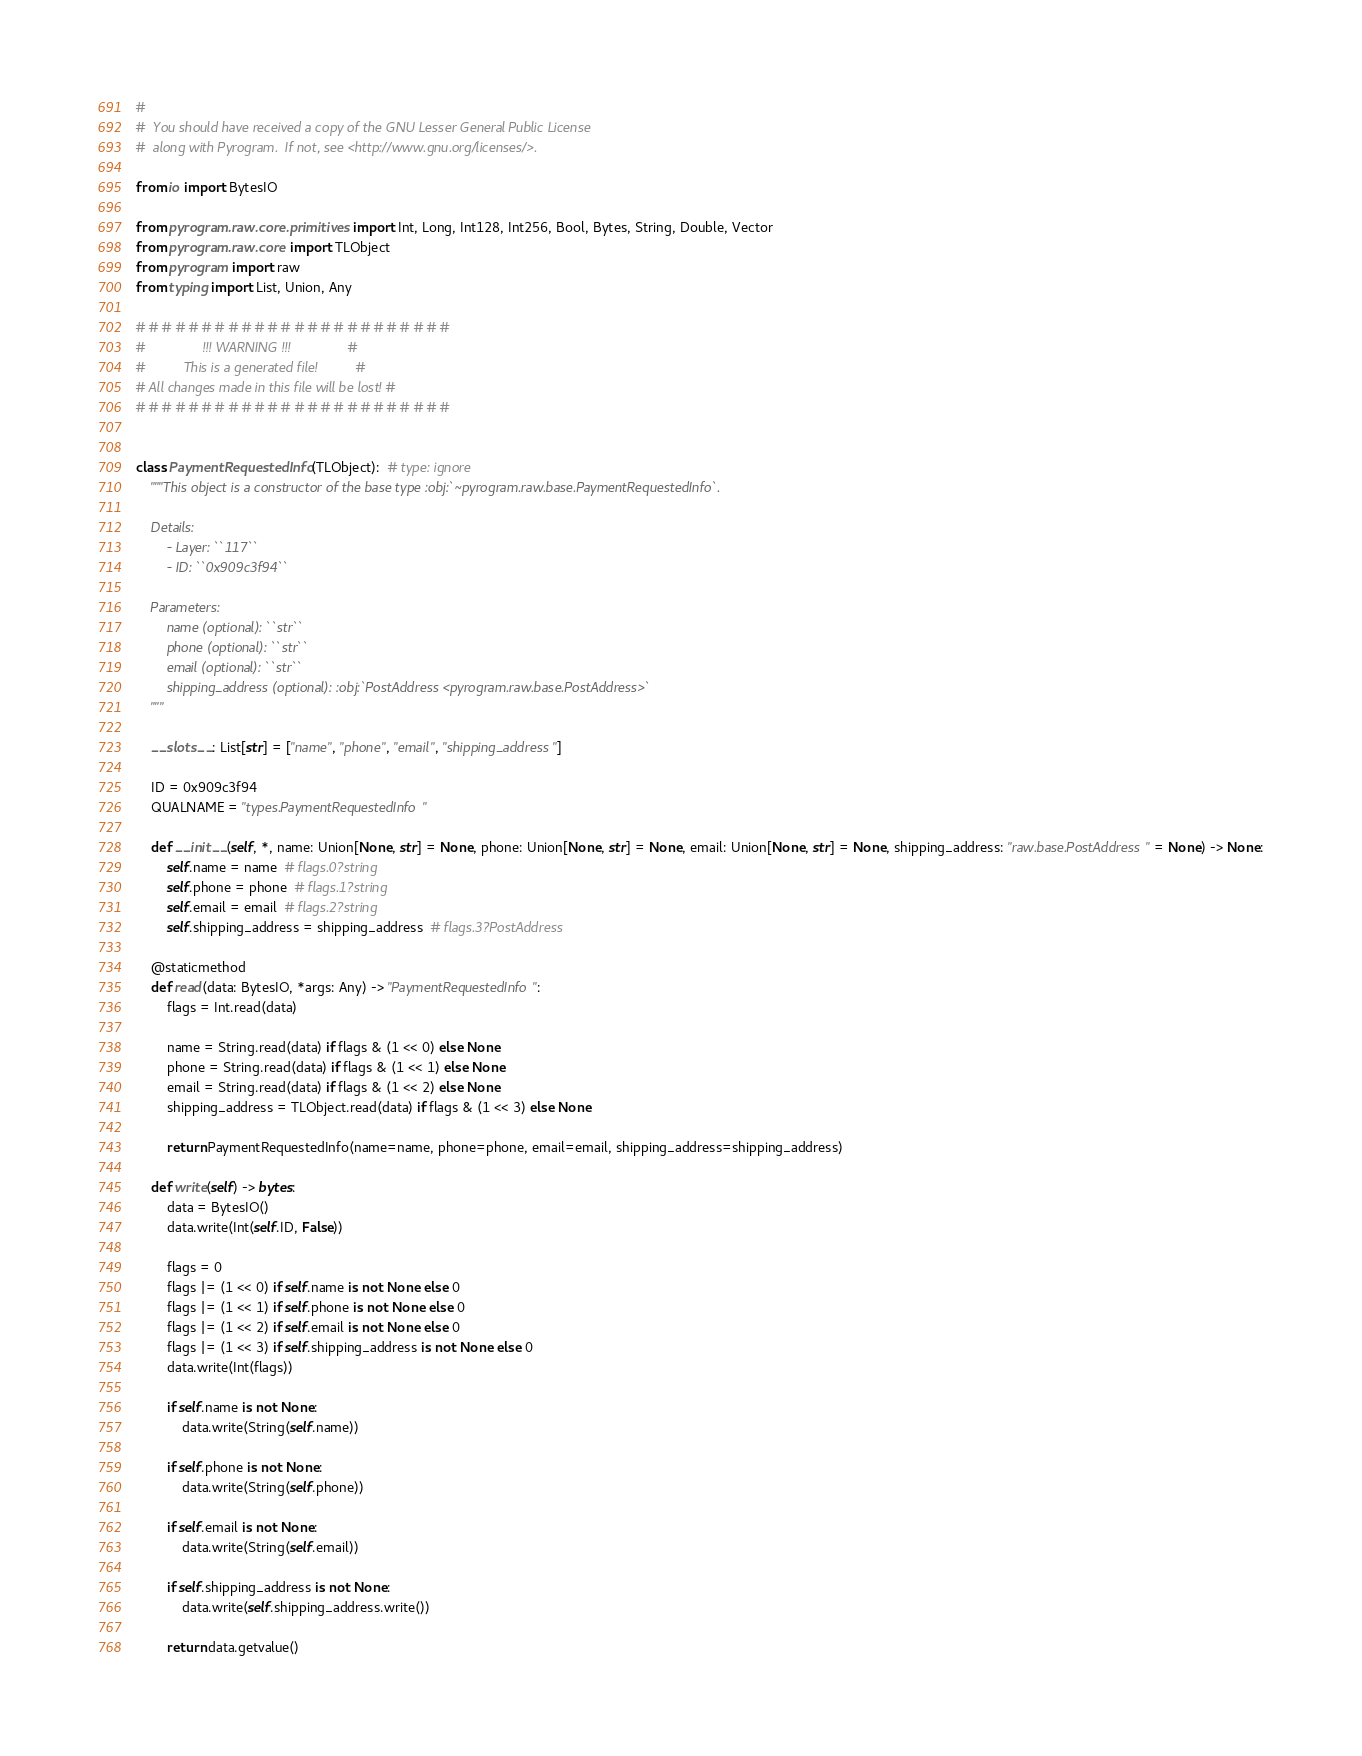Convert code to text. <code><loc_0><loc_0><loc_500><loc_500><_Python_>#
#  You should have received a copy of the GNU Lesser General Public License
#  along with Pyrogram.  If not, see <http://www.gnu.org/licenses/>.

from io import BytesIO

from pyrogram.raw.core.primitives import Int, Long, Int128, Int256, Bool, Bytes, String, Double, Vector
from pyrogram.raw.core import TLObject
from pyrogram import raw
from typing import List, Union, Any

# # # # # # # # # # # # # # # # # # # # # # # #
#               !!! WARNING !!!               #
#          This is a generated file!          #
# All changes made in this file will be lost! #
# # # # # # # # # # # # # # # # # # # # # # # #


class PaymentRequestedInfo(TLObject):  # type: ignore
    """This object is a constructor of the base type :obj:`~pyrogram.raw.base.PaymentRequestedInfo`.

    Details:
        - Layer: ``117``
        - ID: ``0x909c3f94``

    Parameters:
        name (optional): ``str``
        phone (optional): ``str``
        email (optional): ``str``
        shipping_address (optional): :obj:`PostAddress <pyrogram.raw.base.PostAddress>`
    """

    __slots__: List[str] = ["name", "phone", "email", "shipping_address"]

    ID = 0x909c3f94
    QUALNAME = "types.PaymentRequestedInfo"

    def __init__(self, *, name: Union[None, str] = None, phone: Union[None, str] = None, email: Union[None, str] = None, shipping_address: "raw.base.PostAddress" = None) -> None:
        self.name = name  # flags.0?string
        self.phone = phone  # flags.1?string
        self.email = email  # flags.2?string
        self.shipping_address = shipping_address  # flags.3?PostAddress

    @staticmethod
    def read(data: BytesIO, *args: Any) -> "PaymentRequestedInfo":
        flags = Int.read(data)
        
        name = String.read(data) if flags & (1 << 0) else None
        phone = String.read(data) if flags & (1 << 1) else None
        email = String.read(data) if flags & (1 << 2) else None
        shipping_address = TLObject.read(data) if flags & (1 << 3) else None
        
        return PaymentRequestedInfo(name=name, phone=phone, email=email, shipping_address=shipping_address)

    def write(self) -> bytes:
        data = BytesIO()
        data.write(Int(self.ID, False))

        flags = 0
        flags |= (1 << 0) if self.name is not None else 0
        flags |= (1 << 1) if self.phone is not None else 0
        flags |= (1 << 2) if self.email is not None else 0
        flags |= (1 << 3) if self.shipping_address is not None else 0
        data.write(Int(flags))
        
        if self.name is not None:
            data.write(String(self.name))
        
        if self.phone is not None:
            data.write(String(self.phone))
        
        if self.email is not None:
            data.write(String(self.email))
        
        if self.shipping_address is not None:
            data.write(self.shipping_address.write())
        
        return data.getvalue()
</code> 